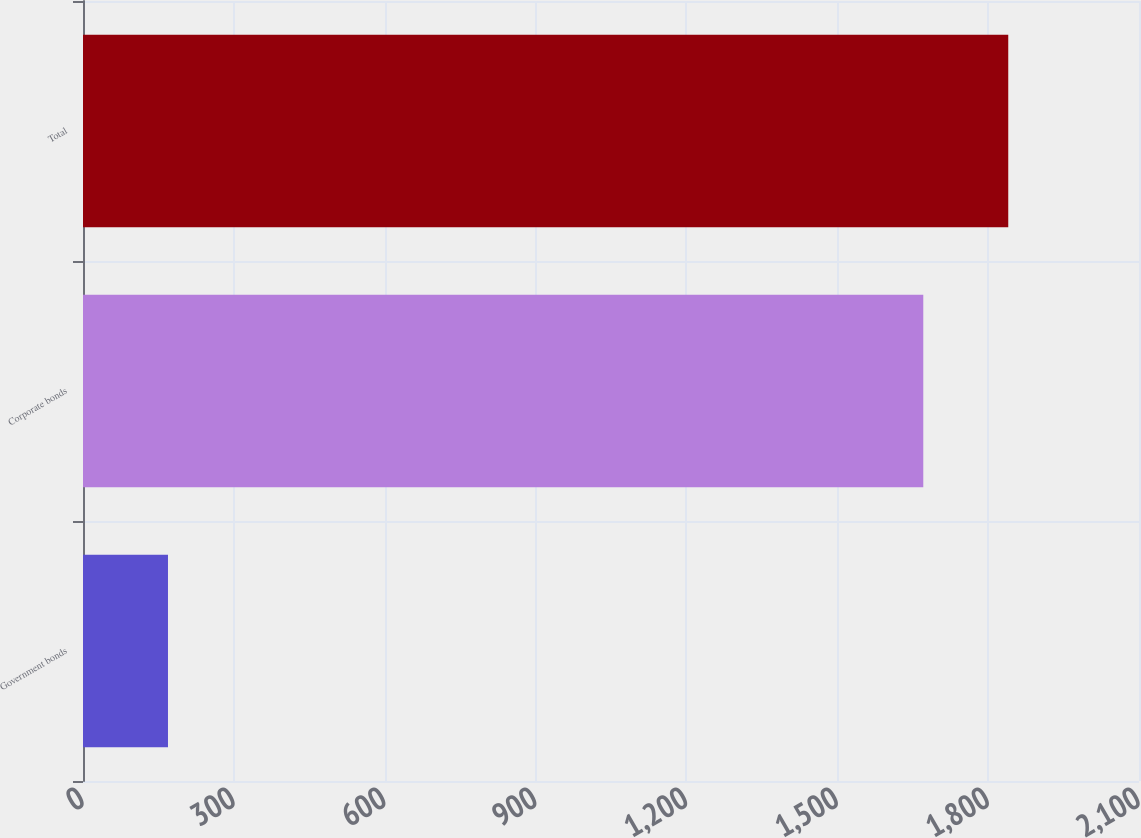<chart> <loc_0><loc_0><loc_500><loc_500><bar_chart><fcel>Government bonds<fcel>Corporate bonds<fcel>Total<nl><fcel>169<fcel>1671<fcel>1840<nl></chart> 